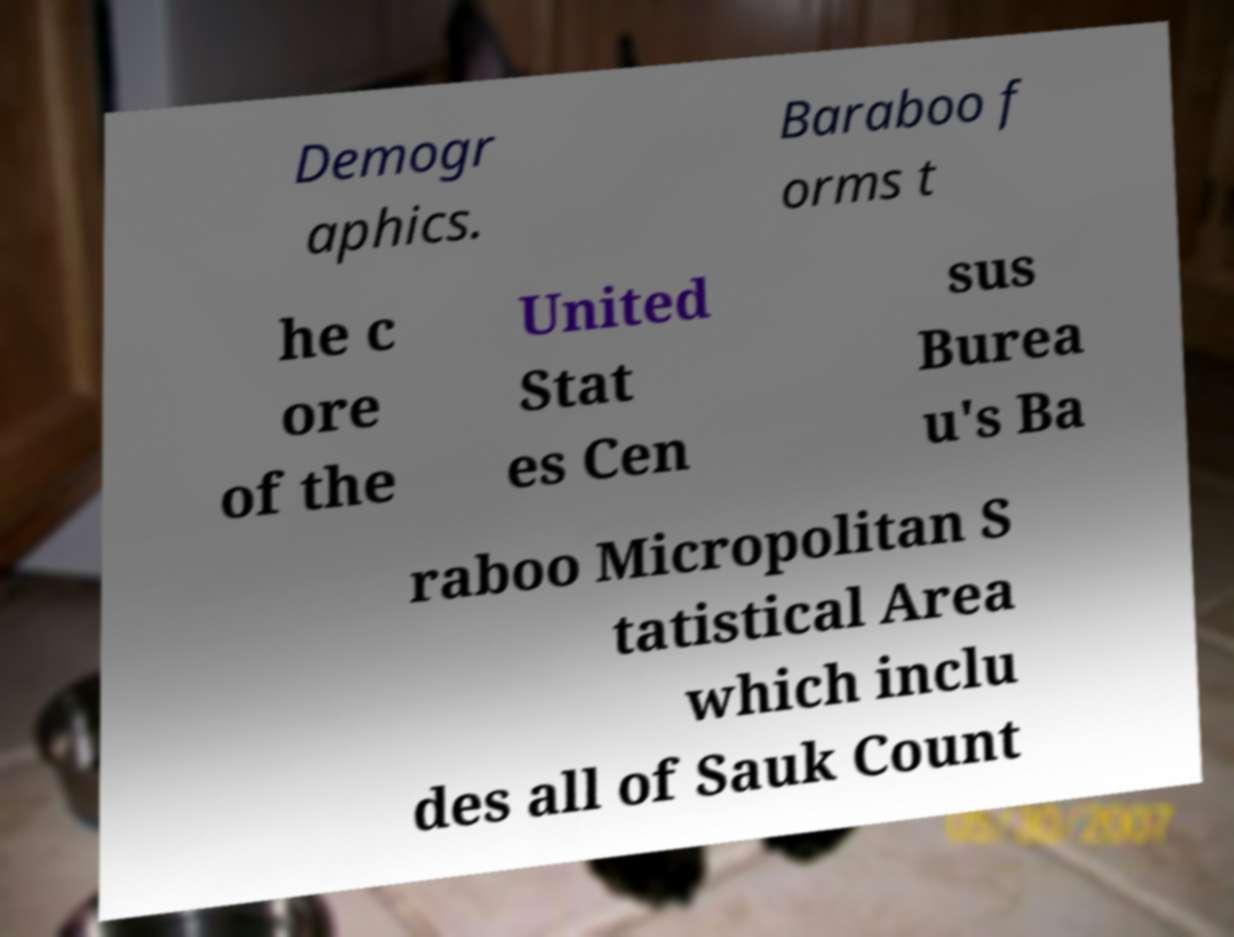There's text embedded in this image that I need extracted. Can you transcribe it verbatim? Demogr aphics. Baraboo f orms t he c ore of the United Stat es Cen sus Burea u's Ba raboo Micropolitan S tatistical Area which inclu des all of Sauk Count 